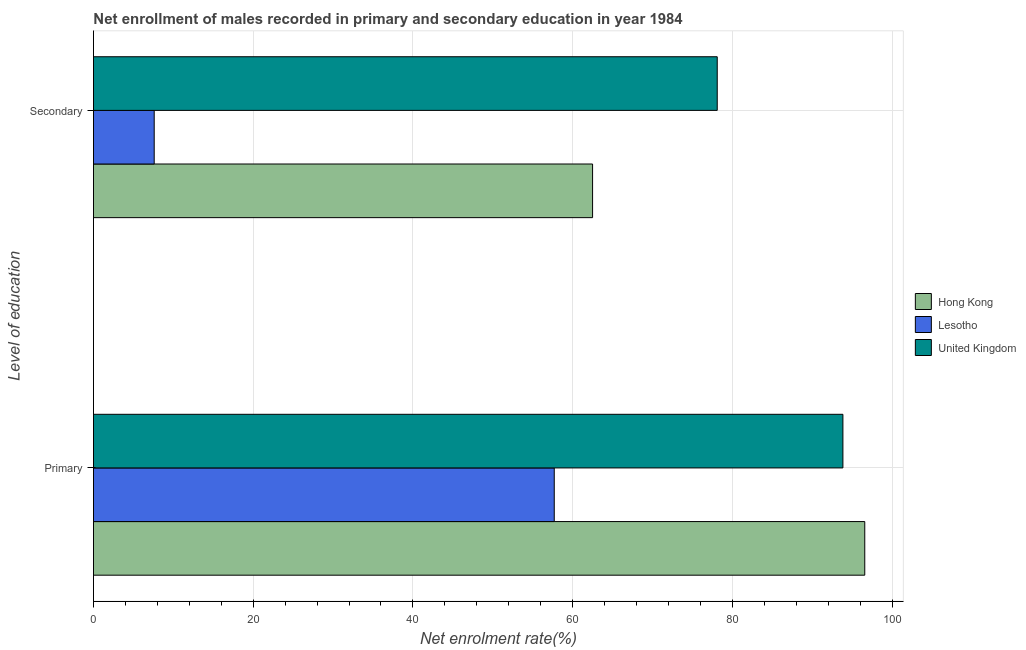Are the number of bars on each tick of the Y-axis equal?
Provide a succinct answer. Yes. How many bars are there on the 1st tick from the bottom?
Offer a very short reply. 3. What is the label of the 2nd group of bars from the top?
Give a very brief answer. Primary. What is the enrollment rate in secondary education in Hong Kong?
Your answer should be compact. 62.5. Across all countries, what is the maximum enrollment rate in primary education?
Offer a terse response. 96.58. Across all countries, what is the minimum enrollment rate in primary education?
Provide a short and direct response. 57.7. In which country was the enrollment rate in primary education minimum?
Your response must be concise. Lesotho. What is the total enrollment rate in secondary education in the graph?
Ensure brevity in your answer.  148.21. What is the difference between the enrollment rate in secondary education in Hong Kong and that in United Kingdom?
Provide a short and direct response. -15.61. What is the difference between the enrollment rate in secondary education in Lesotho and the enrollment rate in primary education in United Kingdom?
Offer a very short reply. -86.24. What is the average enrollment rate in secondary education per country?
Your response must be concise. 49.4. What is the difference between the enrollment rate in primary education and enrollment rate in secondary education in United Kingdom?
Provide a succinct answer. 15.74. What is the ratio of the enrollment rate in primary education in Hong Kong to that in Lesotho?
Offer a terse response. 1.67. In how many countries, is the enrollment rate in primary education greater than the average enrollment rate in primary education taken over all countries?
Offer a terse response. 2. What does the 3rd bar from the top in Primary represents?
Give a very brief answer. Hong Kong. What does the 3rd bar from the bottom in Primary represents?
Your response must be concise. United Kingdom. How many bars are there?
Keep it short and to the point. 6. Are all the bars in the graph horizontal?
Ensure brevity in your answer.  Yes. Does the graph contain grids?
Your answer should be compact. Yes. How many legend labels are there?
Your response must be concise. 3. How are the legend labels stacked?
Ensure brevity in your answer.  Vertical. What is the title of the graph?
Provide a succinct answer. Net enrollment of males recorded in primary and secondary education in year 1984. Does "Croatia" appear as one of the legend labels in the graph?
Your answer should be very brief. No. What is the label or title of the X-axis?
Make the answer very short. Net enrolment rate(%). What is the label or title of the Y-axis?
Keep it short and to the point. Level of education. What is the Net enrolment rate(%) in Hong Kong in Primary?
Provide a short and direct response. 96.58. What is the Net enrolment rate(%) of Lesotho in Primary?
Provide a short and direct response. 57.7. What is the Net enrolment rate(%) of United Kingdom in Primary?
Your response must be concise. 93.84. What is the Net enrolment rate(%) of Hong Kong in Secondary?
Offer a very short reply. 62.5. What is the Net enrolment rate(%) of Lesotho in Secondary?
Your answer should be compact. 7.6. What is the Net enrolment rate(%) in United Kingdom in Secondary?
Make the answer very short. 78.11. Across all Level of education, what is the maximum Net enrolment rate(%) in Hong Kong?
Offer a very short reply. 96.58. Across all Level of education, what is the maximum Net enrolment rate(%) of Lesotho?
Your answer should be compact. 57.7. Across all Level of education, what is the maximum Net enrolment rate(%) of United Kingdom?
Offer a very short reply. 93.84. Across all Level of education, what is the minimum Net enrolment rate(%) of Hong Kong?
Ensure brevity in your answer.  62.5. Across all Level of education, what is the minimum Net enrolment rate(%) in Lesotho?
Your response must be concise. 7.6. Across all Level of education, what is the minimum Net enrolment rate(%) of United Kingdom?
Ensure brevity in your answer.  78.11. What is the total Net enrolment rate(%) in Hong Kong in the graph?
Your response must be concise. 159.08. What is the total Net enrolment rate(%) in Lesotho in the graph?
Your answer should be compact. 65.3. What is the total Net enrolment rate(%) of United Kingdom in the graph?
Make the answer very short. 171.95. What is the difference between the Net enrolment rate(%) in Hong Kong in Primary and that in Secondary?
Your answer should be very brief. 34.08. What is the difference between the Net enrolment rate(%) of Lesotho in Primary and that in Secondary?
Provide a short and direct response. 50.09. What is the difference between the Net enrolment rate(%) of United Kingdom in Primary and that in Secondary?
Give a very brief answer. 15.73. What is the difference between the Net enrolment rate(%) of Hong Kong in Primary and the Net enrolment rate(%) of Lesotho in Secondary?
Give a very brief answer. 88.98. What is the difference between the Net enrolment rate(%) in Hong Kong in Primary and the Net enrolment rate(%) in United Kingdom in Secondary?
Offer a very short reply. 18.47. What is the difference between the Net enrolment rate(%) of Lesotho in Primary and the Net enrolment rate(%) of United Kingdom in Secondary?
Your answer should be compact. -20.41. What is the average Net enrolment rate(%) of Hong Kong per Level of education?
Offer a very short reply. 79.54. What is the average Net enrolment rate(%) in Lesotho per Level of education?
Keep it short and to the point. 32.65. What is the average Net enrolment rate(%) of United Kingdom per Level of education?
Keep it short and to the point. 85.98. What is the difference between the Net enrolment rate(%) of Hong Kong and Net enrolment rate(%) of Lesotho in Primary?
Offer a terse response. 38.88. What is the difference between the Net enrolment rate(%) in Hong Kong and Net enrolment rate(%) in United Kingdom in Primary?
Ensure brevity in your answer.  2.74. What is the difference between the Net enrolment rate(%) in Lesotho and Net enrolment rate(%) in United Kingdom in Primary?
Provide a short and direct response. -36.15. What is the difference between the Net enrolment rate(%) of Hong Kong and Net enrolment rate(%) of Lesotho in Secondary?
Ensure brevity in your answer.  54.89. What is the difference between the Net enrolment rate(%) in Hong Kong and Net enrolment rate(%) in United Kingdom in Secondary?
Your answer should be compact. -15.61. What is the difference between the Net enrolment rate(%) in Lesotho and Net enrolment rate(%) in United Kingdom in Secondary?
Your answer should be very brief. -70.5. What is the ratio of the Net enrolment rate(%) in Hong Kong in Primary to that in Secondary?
Provide a short and direct response. 1.55. What is the ratio of the Net enrolment rate(%) of Lesotho in Primary to that in Secondary?
Keep it short and to the point. 7.59. What is the ratio of the Net enrolment rate(%) in United Kingdom in Primary to that in Secondary?
Keep it short and to the point. 1.2. What is the difference between the highest and the second highest Net enrolment rate(%) of Hong Kong?
Provide a short and direct response. 34.08. What is the difference between the highest and the second highest Net enrolment rate(%) in Lesotho?
Your response must be concise. 50.09. What is the difference between the highest and the second highest Net enrolment rate(%) of United Kingdom?
Provide a short and direct response. 15.73. What is the difference between the highest and the lowest Net enrolment rate(%) in Hong Kong?
Provide a succinct answer. 34.08. What is the difference between the highest and the lowest Net enrolment rate(%) in Lesotho?
Offer a very short reply. 50.09. What is the difference between the highest and the lowest Net enrolment rate(%) of United Kingdom?
Make the answer very short. 15.73. 